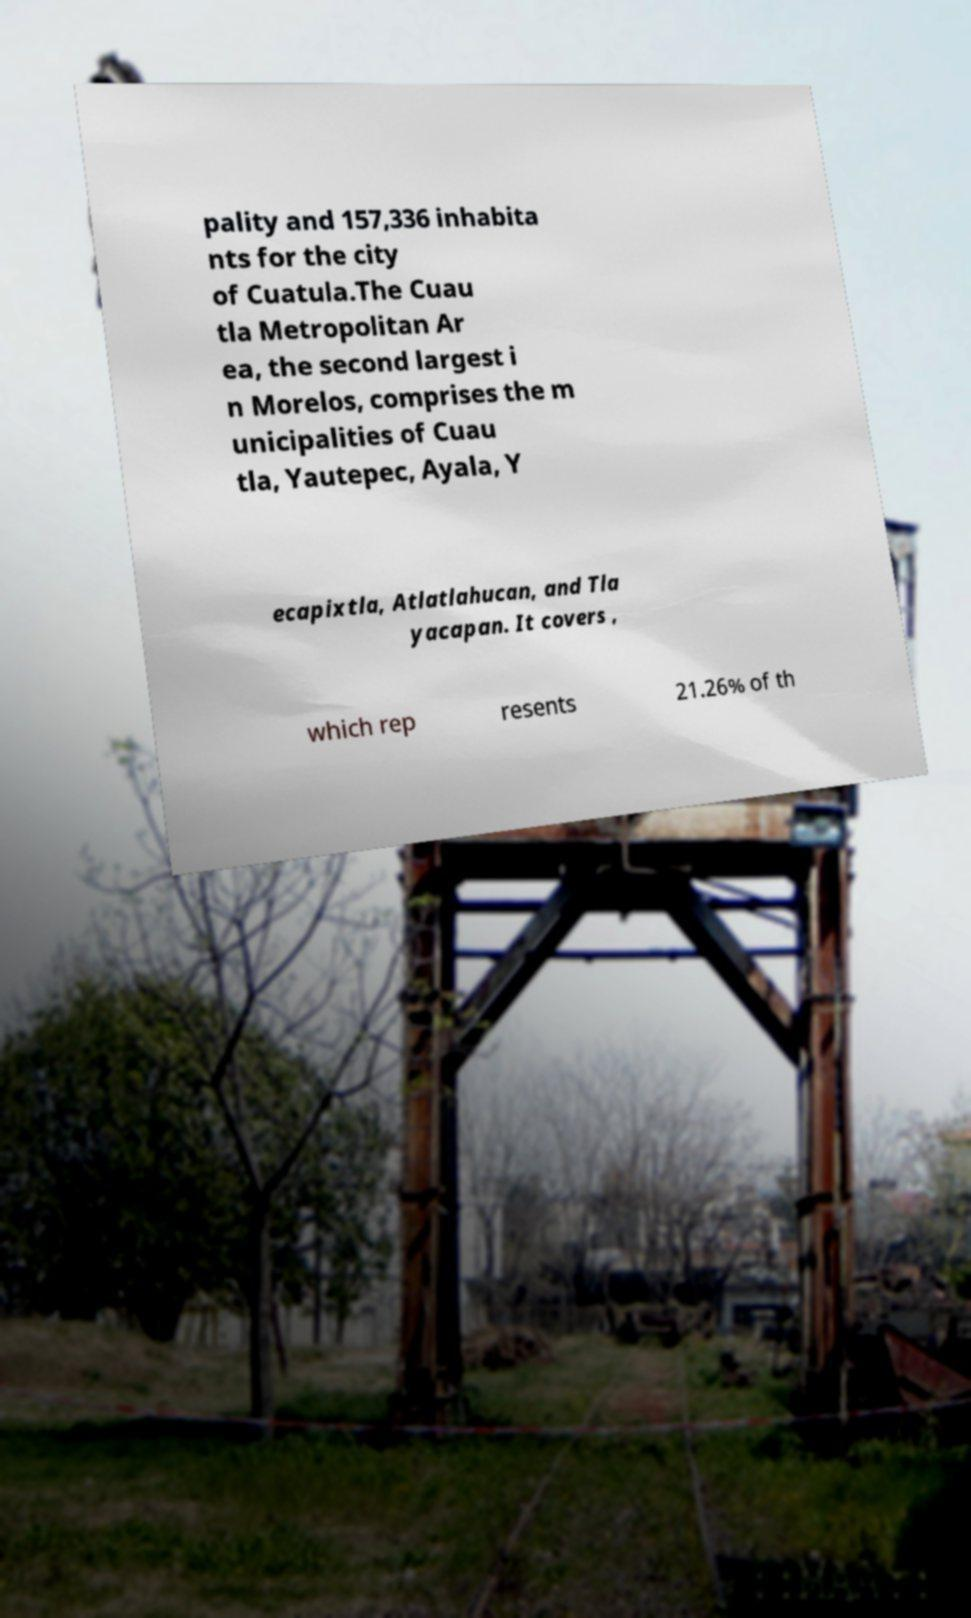Can you accurately transcribe the text from the provided image for me? pality and 157,336 inhabita nts for the city of Cuatula.The Cuau tla Metropolitan Ar ea, the second largest i n Morelos, comprises the m unicipalities of Cuau tla, Yautepec, Ayala, Y ecapixtla, Atlatlahucan, and Tla yacapan. It covers , which rep resents 21.26% of th 